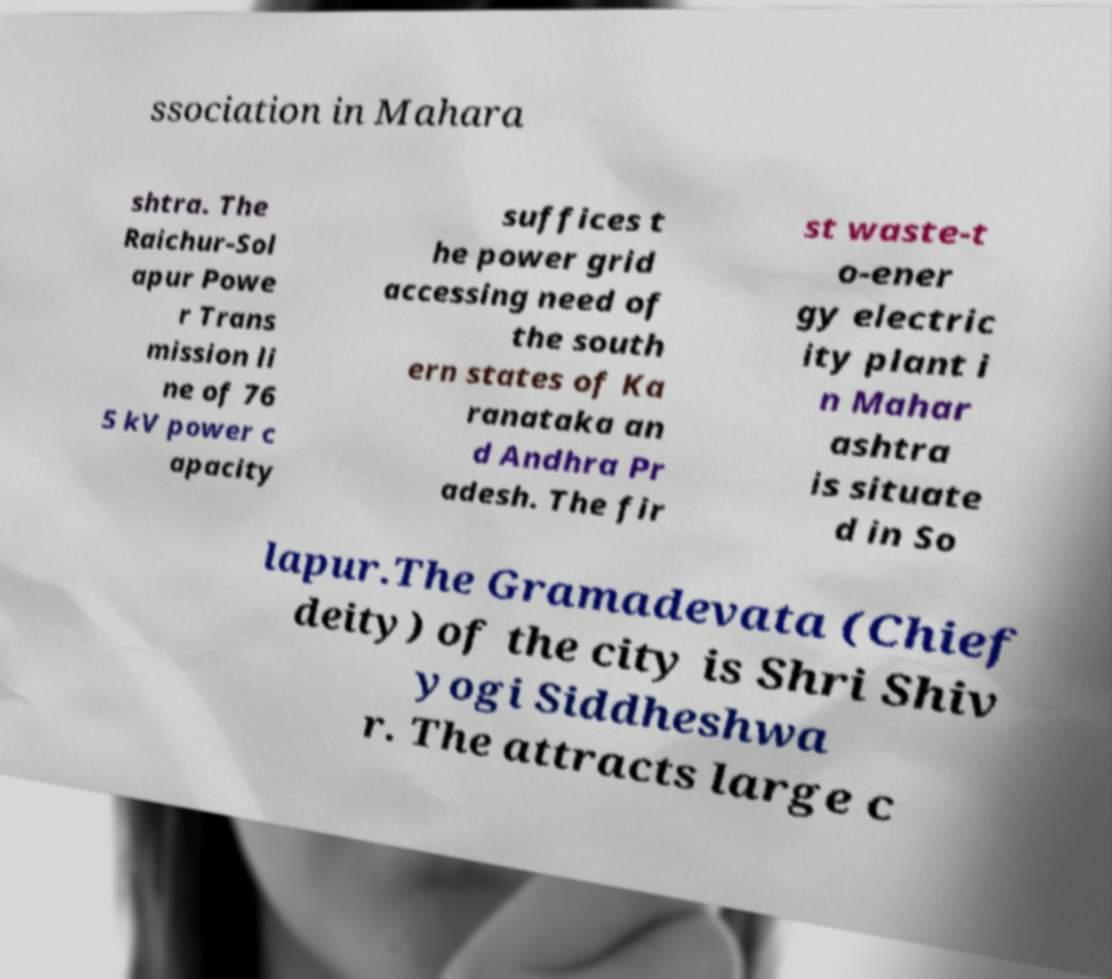For documentation purposes, I need the text within this image transcribed. Could you provide that? ssociation in Mahara shtra. The Raichur-Sol apur Powe r Trans mission li ne of 76 5 kV power c apacity suffices t he power grid accessing need of the south ern states of Ka ranataka an d Andhra Pr adesh. The fir st waste-t o-ener gy electric ity plant i n Mahar ashtra is situate d in So lapur.The Gramadevata (Chief deity) of the city is Shri Shiv yogi Siddheshwa r. The attracts large c 